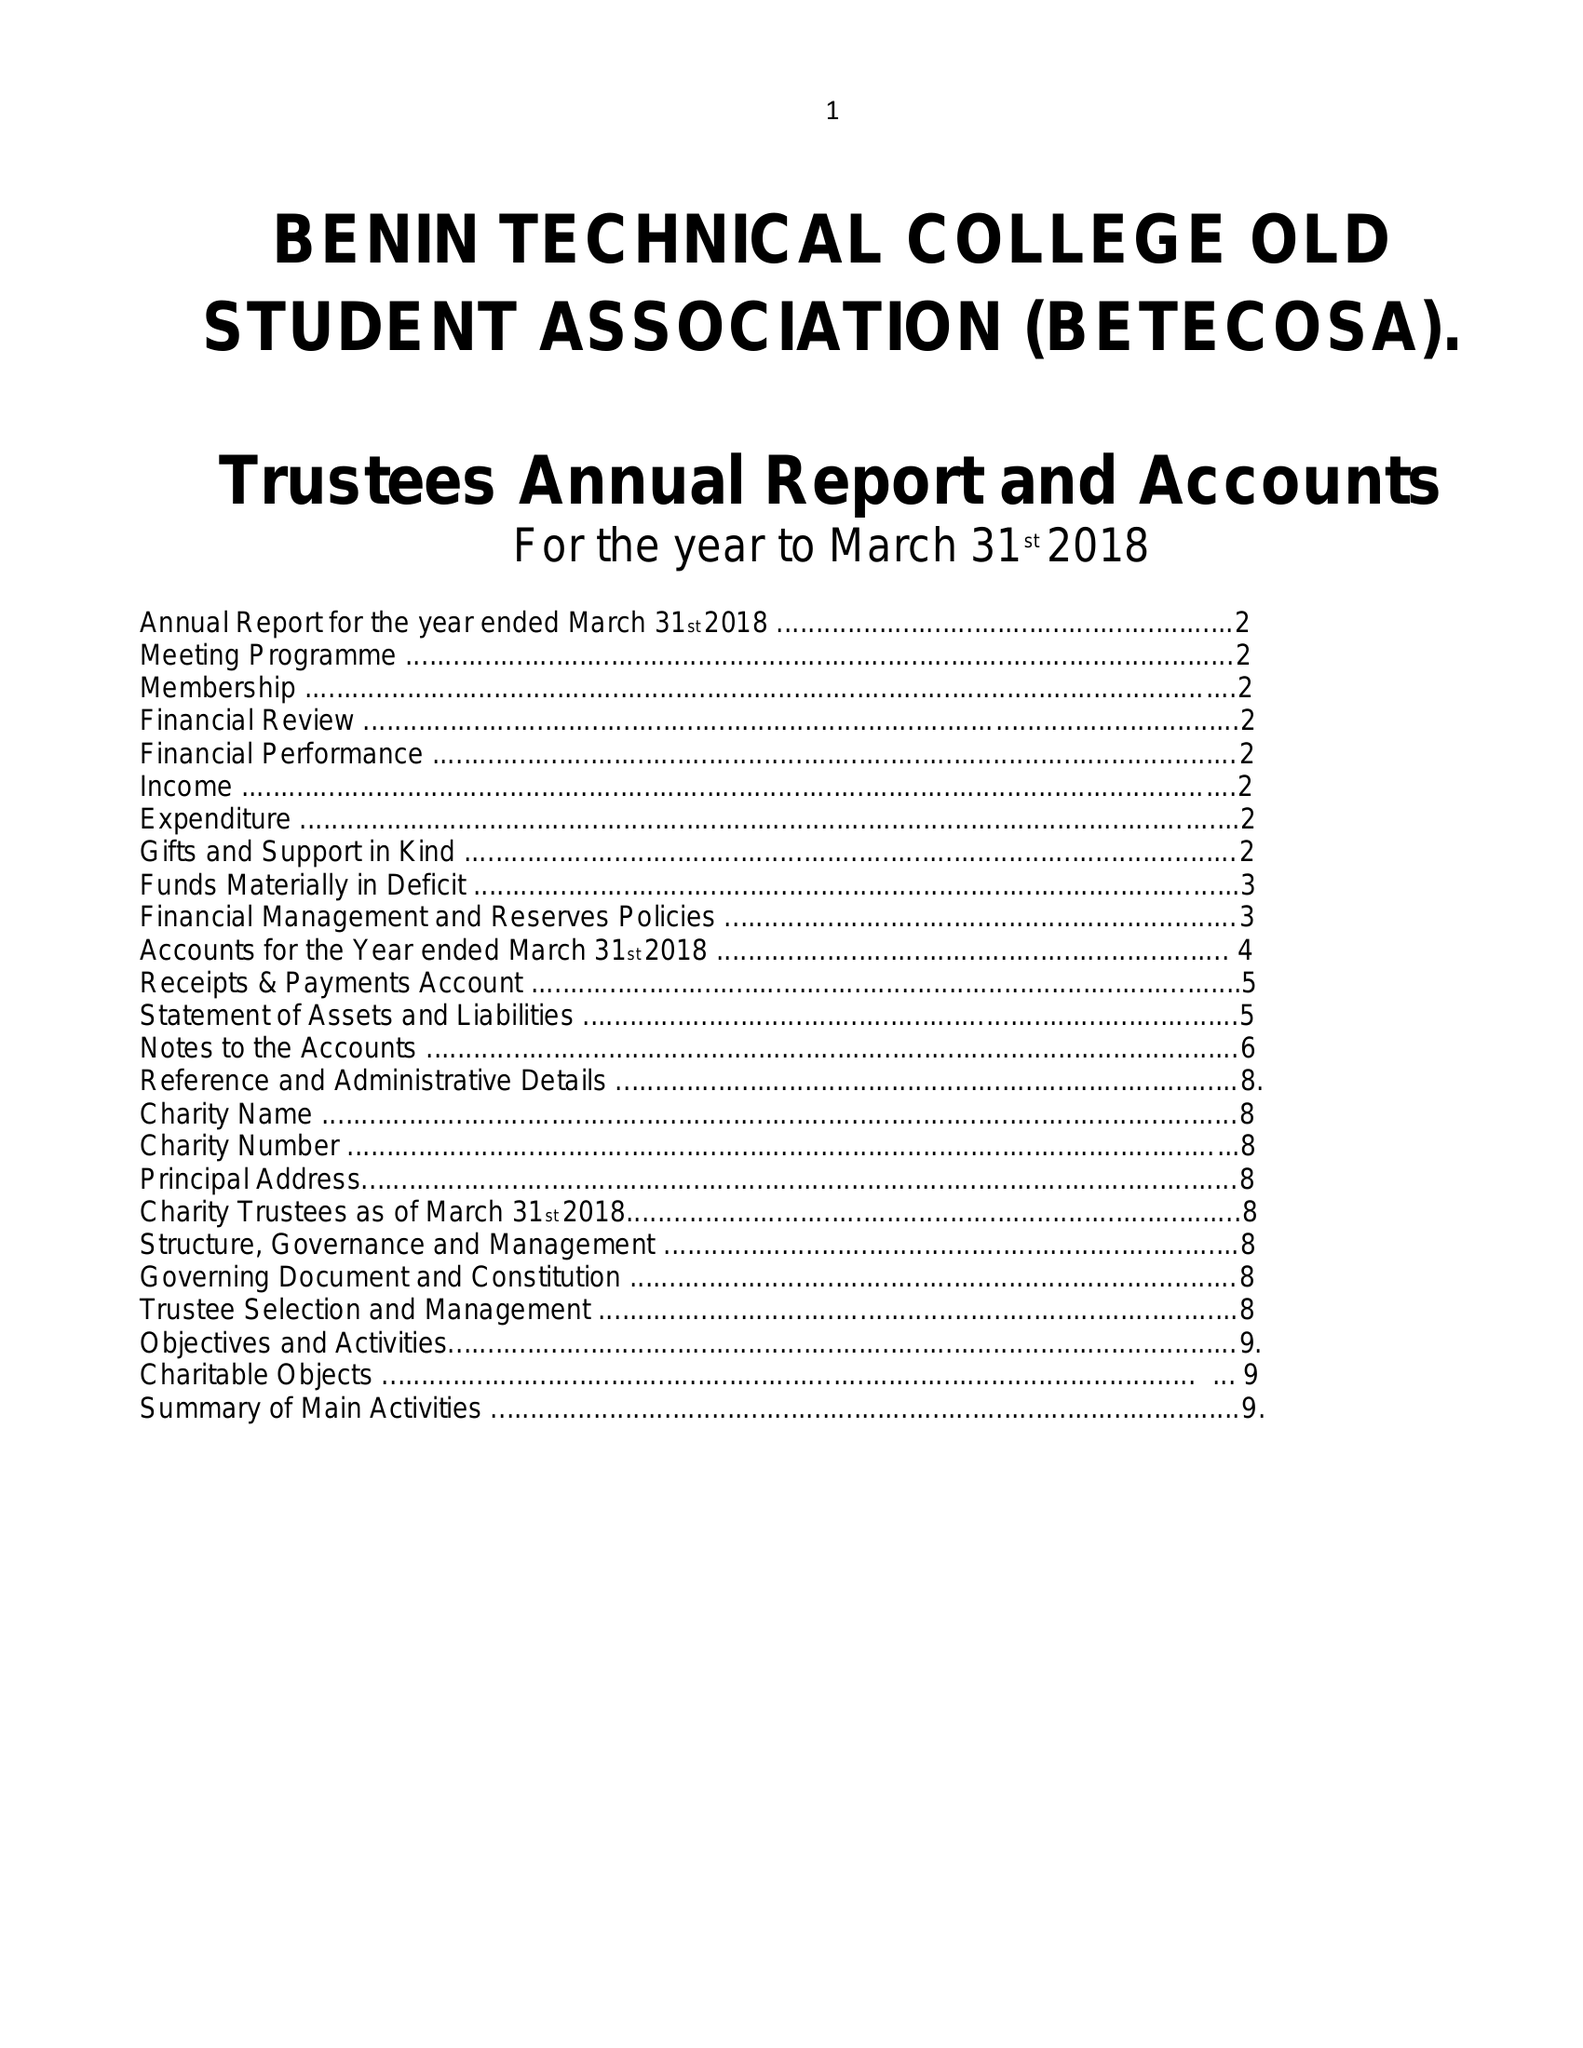What is the value for the report_date?
Answer the question using a single word or phrase. 2018-03-31 